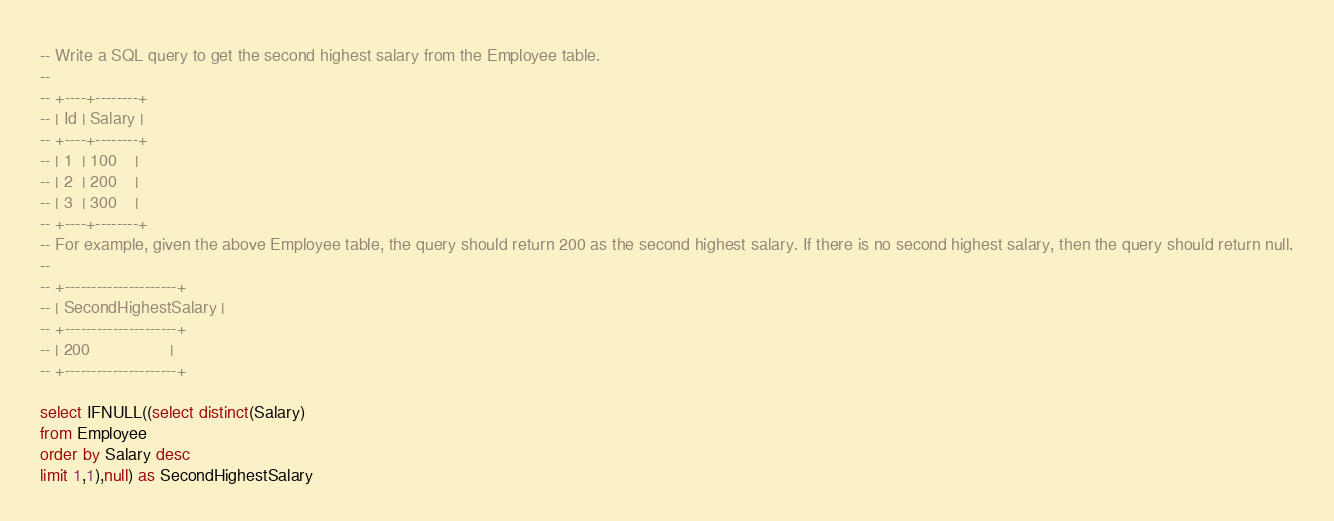Convert code to text. <code><loc_0><loc_0><loc_500><loc_500><_SQL_>-- Write a SQL query to get the second highest salary from the Employee table.
-- 
-- +----+--------+
-- | Id | Salary |
-- +----+--------+
-- | 1  | 100    |
-- | 2  | 200    |
-- | 3  | 300    |
-- +----+--------+
-- For example, given the above Employee table, the query should return 200 as the second highest salary. If there is no second highest salary, then the query should return null.
-- 
-- +---------------------+
-- | SecondHighestSalary |
-- +---------------------+
-- | 200                 |
-- +---------------------+

select IFNULL((select distinct(Salary) 
from Employee
order by Salary desc
limit 1,1),null) as SecondHighestSalary

</code> 